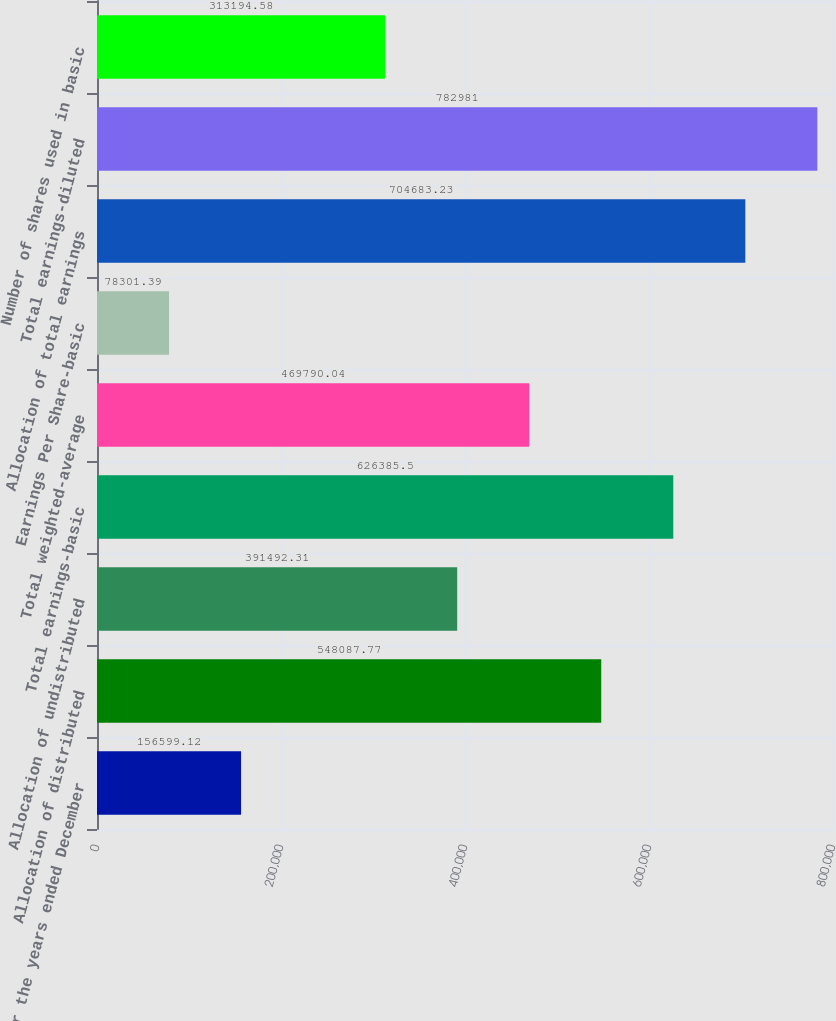<chart> <loc_0><loc_0><loc_500><loc_500><bar_chart><fcel>For the years ended December<fcel>Allocation of distributed<fcel>Allocation of undistributed<fcel>Total earnings-basic<fcel>Total weighted-average<fcel>Earnings Per Share-basic<fcel>Allocation of total earnings<fcel>Total earnings-diluted<fcel>Number of shares used in basic<nl><fcel>156599<fcel>548088<fcel>391492<fcel>626386<fcel>469790<fcel>78301.4<fcel>704683<fcel>782981<fcel>313195<nl></chart> 